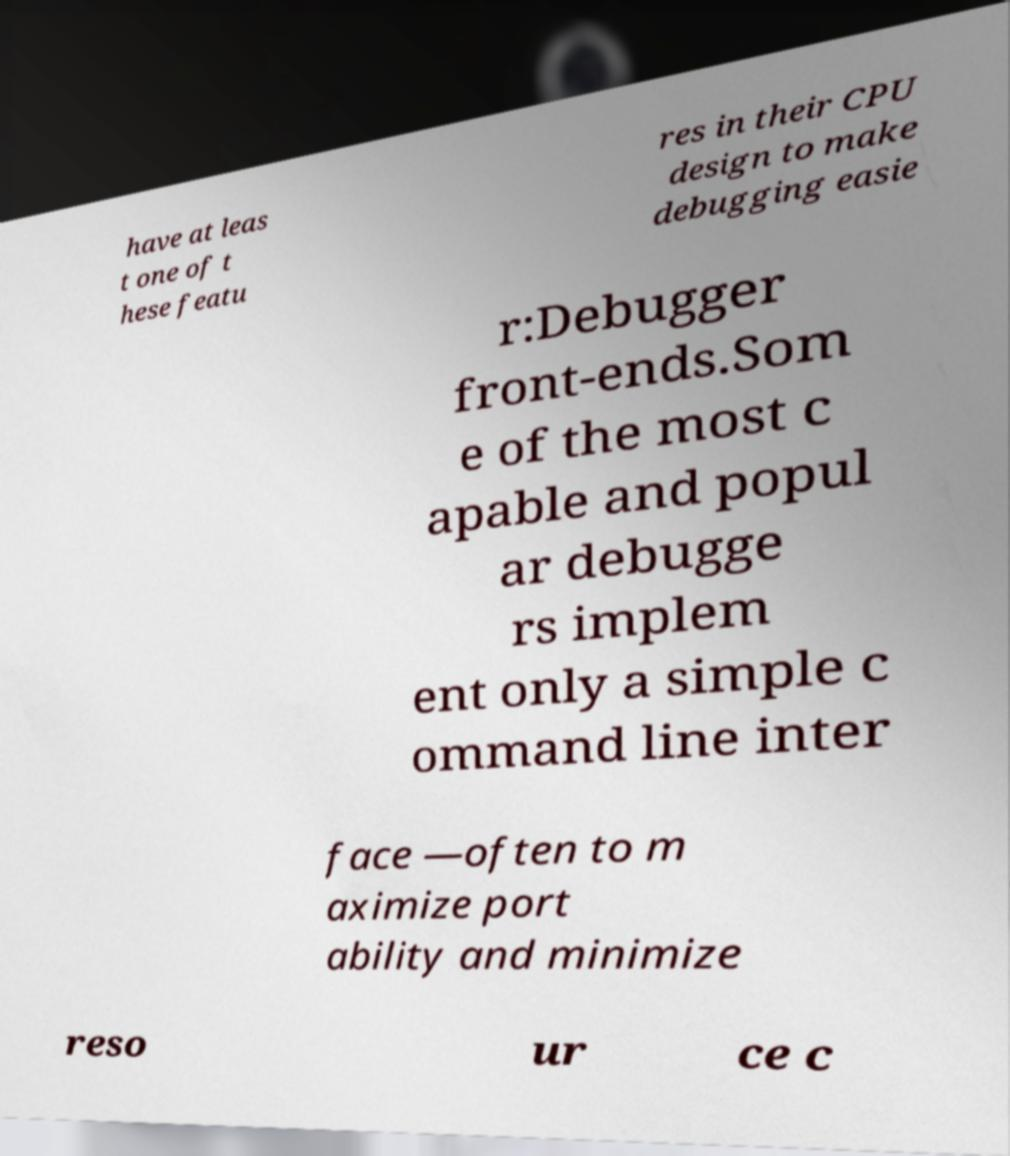Please read and relay the text visible in this image. What does it say? have at leas t one of t hese featu res in their CPU design to make debugging easie r:Debugger front-ends.Som e of the most c apable and popul ar debugge rs implem ent only a simple c ommand line inter face —often to m aximize port ability and minimize reso ur ce c 